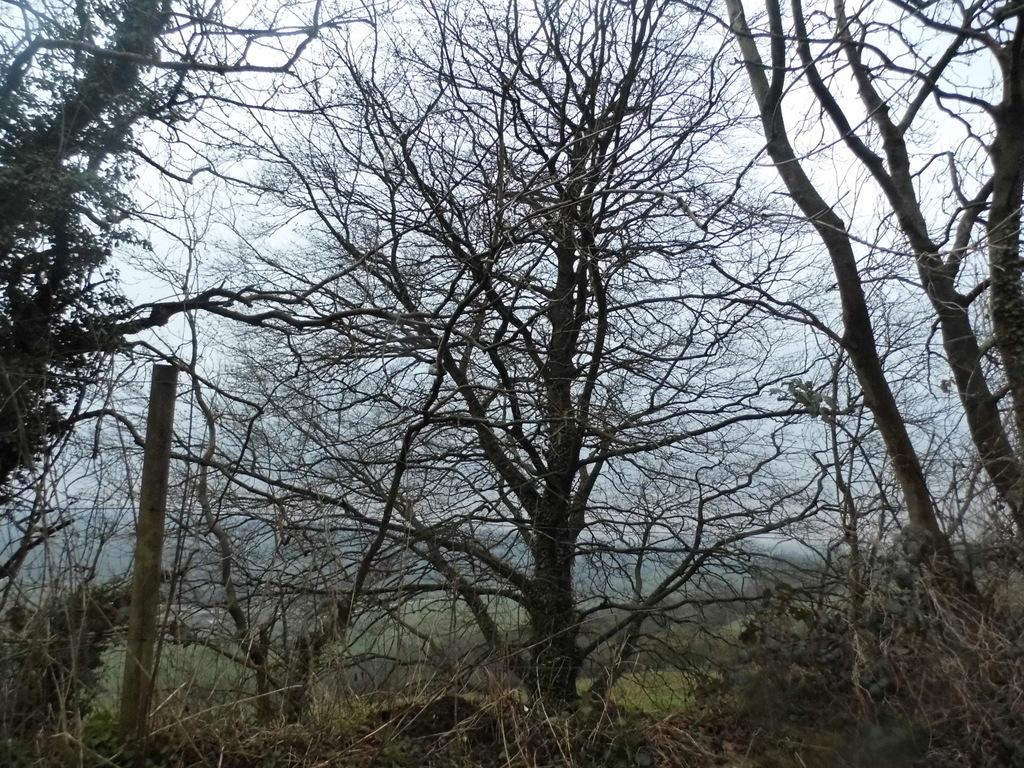What type of vegetation can be seen in the image? There are trees in the image. What structure is present in the image? There is a pole in the image. What can be seen in the distance in the image? The sky is visible in the background of the image. Can you tell me how many boats are tied to the pole in the image? There are no boats present in the image; it features trees and a pole. What type of lace is draped over the trees in the image? There is no lace present in the image; it features trees and a pole. 